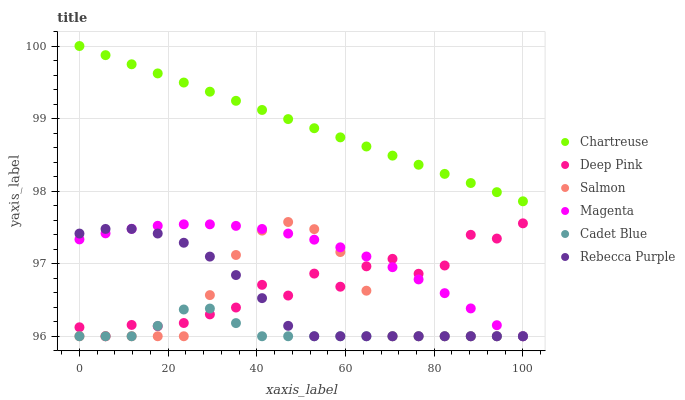Does Cadet Blue have the minimum area under the curve?
Answer yes or no. Yes. Does Chartreuse have the maximum area under the curve?
Answer yes or no. Yes. Does Salmon have the minimum area under the curve?
Answer yes or no. No. Does Salmon have the maximum area under the curve?
Answer yes or no. No. Is Chartreuse the smoothest?
Answer yes or no. Yes. Is Deep Pink the roughest?
Answer yes or no. Yes. Is Salmon the smoothest?
Answer yes or no. No. Is Salmon the roughest?
Answer yes or no. No. Does Cadet Blue have the lowest value?
Answer yes or no. Yes. Does Chartreuse have the lowest value?
Answer yes or no. No. Does Chartreuse have the highest value?
Answer yes or no. Yes. Does Salmon have the highest value?
Answer yes or no. No. Is Deep Pink less than Chartreuse?
Answer yes or no. Yes. Is Chartreuse greater than Magenta?
Answer yes or no. Yes. Does Cadet Blue intersect Magenta?
Answer yes or no. Yes. Is Cadet Blue less than Magenta?
Answer yes or no. No. Is Cadet Blue greater than Magenta?
Answer yes or no. No. Does Deep Pink intersect Chartreuse?
Answer yes or no. No. 